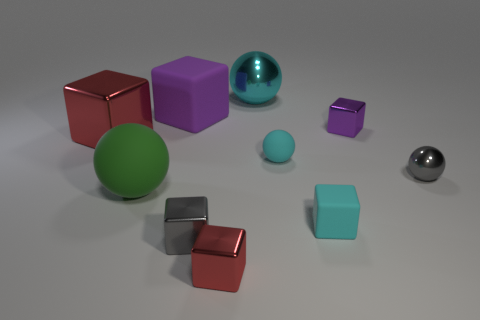Are there any red matte blocks of the same size as the cyan matte cube?
Provide a short and direct response. No. Does the big red object have the same material as the small gray sphere?
Offer a very short reply. Yes. What number of objects are either small blue shiny things or tiny metal objects?
Offer a terse response. 4. What size is the cyan shiny sphere?
Your answer should be compact. Large. Is the number of tiny gray things less than the number of cyan rubber balls?
Provide a short and direct response. No. How many objects have the same color as the large rubber sphere?
Make the answer very short. 0. There is a ball left of the gray metal block; is its color the same as the small rubber cube?
Provide a short and direct response. No. What shape is the red metallic thing in front of the large rubber sphere?
Ensure brevity in your answer.  Cube. Is there a small gray thing that is on the left side of the metal object in front of the gray block?
Ensure brevity in your answer.  Yes. What number of red things are the same material as the small cyan ball?
Provide a short and direct response. 0. 